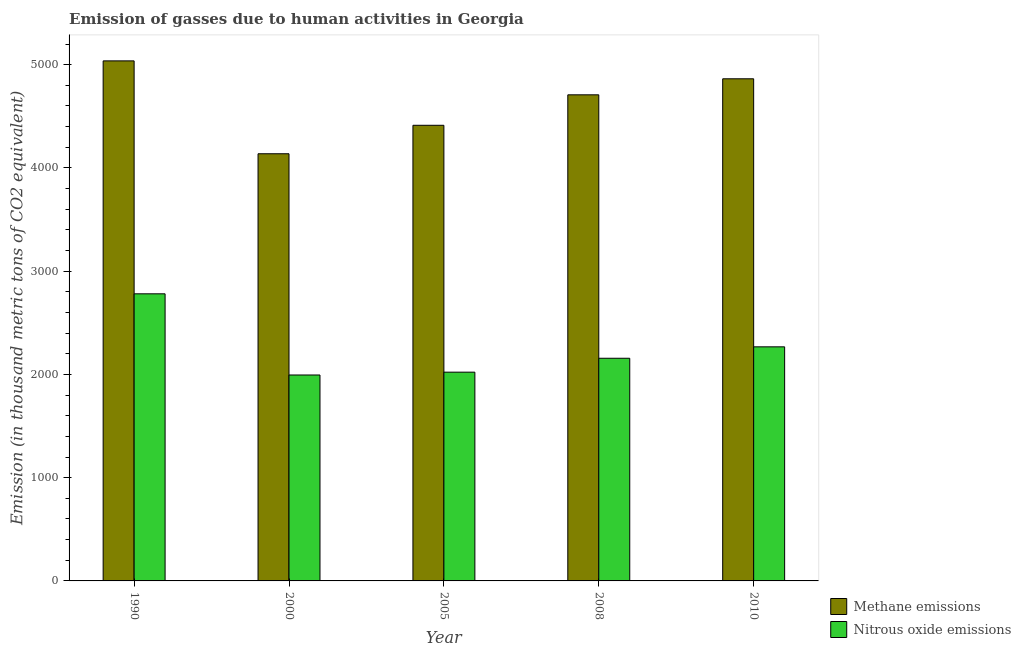Are the number of bars per tick equal to the number of legend labels?
Your answer should be compact. Yes. How many bars are there on the 5th tick from the left?
Make the answer very short. 2. What is the amount of nitrous oxide emissions in 2010?
Offer a very short reply. 2267.3. Across all years, what is the maximum amount of nitrous oxide emissions?
Give a very brief answer. 2780.8. Across all years, what is the minimum amount of nitrous oxide emissions?
Ensure brevity in your answer.  1994.5. In which year was the amount of nitrous oxide emissions maximum?
Your answer should be compact. 1990. What is the total amount of methane emissions in the graph?
Offer a terse response. 2.32e+04. What is the difference between the amount of methane emissions in 2005 and that in 2008?
Ensure brevity in your answer.  -295. What is the difference between the amount of methane emissions in 2000 and the amount of nitrous oxide emissions in 2010?
Provide a short and direct response. -726.1. What is the average amount of nitrous oxide emissions per year?
Provide a short and direct response. 2244.24. In the year 2010, what is the difference between the amount of nitrous oxide emissions and amount of methane emissions?
Keep it short and to the point. 0. In how many years, is the amount of nitrous oxide emissions greater than 4200 thousand metric tons?
Your answer should be compact. 0. What is the ratio of the amount of nitrous oxide emissions in 2000 to that in 2008?
Make the answer very short. 0.92. What is the difference between the highest and the second highest amount of methane emissions?
Your response must be concise. 173.5. What is the difference between the highest and the lowest amount of nitrous oxide emissions?
Your answer should be very brief. 786.3. What does the 1st bar from the left in 2008 represents?
Offer a terse response. Methane emissions. What does the 1st bar from the right in 2010 represents?
Your response must be concise. Nitrous oxide emissions. How many bars are there?
Make the answer very short. 10. How many years are there in the graph?
Give a very brief answer. 5. What is the difference between two consecutive major ticks on the Y-axis?
Give a very brief answer. 1000. Does the graph contain any zero values?
Your answer should be compact. No. Where does the legend appear in the graph?
Your response must be concise. Bottom right. How many legend labels are there?
Your response must be concise. 2. How are the legend labels stacked?
Offer a very short reply. Vertical. What is the title of the graph?
Offer a very short reply. Emission of gasses due to human activities in Georgia. Does "2012 US$" appear as one of the legend labels in the graph?
Your answer should be compact. No. What is the label or title of the X-axis?
Keep it short and to the point. Year. What is the label or title of the Y-axis?
Keep it short and to the point. Emission (in thousand metric tons of CO2 equivalent). What is the Emission (in thousand metric tons of CO2 equivalent) of Methane emissions in 1990?
Offer a terse response. 5037. What is the Emission (in thousand metric tons of CO2 equivalent) in Nitrous oxide emissions in 1990?
Your answer should be very brief. 2780.8. What is the Emission (in thousand metric tons of CO2 equivalent) in Methane emissions in 2000?
Give a very brief answer. 4137.4. What is the Emission (in thousand metric tons of CO2 equivalent) in Nitrous oxide emissions in 2000?
Provide a short and direct response. 1994.5. What is the Emission (in thousand metric tons of CO2 equivalent) of Methane emissions in 2005?
Ensure brevity in your answer.  4413.2. What is the Emission (in thousand metric tons of CO2 equivalent) of Nitrous oxide emissions in 2005?
Provide a short and direct response. 2022. What is the Emission (in thousand metric tons of CO2 equivalent) in Methane emissions in 2008?
Keep it short and to the point. 4708.2. What is the Emission (in thousand metric tons of CO2 equivalent) of Nitrous oxide emissions in 2008?
Your answer should be compact. 2156.6. What is the Emission (in thousand metric tons of CO2 equivalent) of Methane emissions in 2010?
Provide a succinct answer. 4863.5. What is the Emission (in thousand metric tons of CO2 equivalent) of Nitrous oxide emissions in 2010?
Make the answer very short. 2267.3. Across all years, what is the maximum Emission (in thousand metric tons of CO2 equivalent) of Methane emissions?
Provide a succinct answer. 5037. Across all years, what is the maximum Emission (in thousand metric tons of CO2 equivalent) of Nitrous oxide emissions?
Give a very brief answer. 2780.8. Across all years, what is the minimum Emission (in thousand metric tons of CO2 equivalent) in Methane emissions?
Give a very brief answer. 4137.4. Across all years, what is the minimum Emission (in thousand metric tons of CO2 equivalent) of Nitrous oxide emissions?
Offer a very short reply. 1994.5. What is the total Emission (in thousand metric tons of CO2 equivalent) in Methane emissions in the graph?
Ensure brevity in your answer.  2.32e+04. What is the total Emission (in thousand metric tons of CO2 equivalent) in Nitrous oxide emissions in the graph?
Offer a terse response. 1.12e+04. What is the difference between the Emission (in thousand metric tons of CO2 equivalent) in Methane emissions in 1990 and that in 2000?
Offer a terse response. 899.6. What is the difference between the Emission (in thousand metric tons of CO2 equivalent) of Nitrous oxide emissions in 1990 and that in 2000?
Your answer should be compact. 786.3. What is the difference between the Emission (in thousand metric tons of CO2 equivalent) in Methane emissions in 1990 and that in 2005?
Your answer should be very brief. 623.8. What is the difference between the Emission (in thousand metric tons of CO2 equivalent) of Nitrous oxide emissions in 1990 and that in 2005?
Keep it short and to the point. 758.8. What is the difference between the Emission (in thousand metric tons of CO2 equivalent) of Methane emissions in 1990 and that in 2008?
Give a very brief answer. 328.8. What is the difference between the Emission (in thousand metric tons of CO2 equivalent) of Nitrous oxide emissions in 1990 and that in 2008?
Your answer should be very brief. 624.2. What is the difference between the Emission (in thousand metric tons of CO2 equivalent) of Methane emissions in 1990 and that in 2010?
Provide a succinct answer. 173.5. What is the difference between the Emission (in thousand metric tons of CO2 equivalent) of Nitrous oxide emissions in 1990 and that in 2010?
Give a very brief answer. 513.5. What is the difference between the Emission (in thousand metric tons of CO2 equivalent) in Methane emissions in 2000 and that in 2005?
Ensure brevity in your answer.  -275.8. What is the difference between the Emission (in thousand metric tons of CO2 equivalent) in Nitrous oxide emissions in 2000 and that in 2005?
Offer a very short reply. -27.5. What is the difference between the Emission (in thousand metric tons of CO2 equivalent) of Methane emissions in 2000 and that in 2008?
Your response must be concise. -570.8. What is the difference between the Emission (in thousand metric tons of CO2 equivalent) of Nitrous oxide emissions in 2000 and that in 2008?
Keep it short and to the point. -162.1. What is the difference between the Emission (in thousand metric tons of CO2 equivalent) of Methane emissions in 2000 and that in 2010?
Offer a very short reply. -726.1. What is the difference between the Emission (in thousand metric tons of CO2 equivalent) in Nitrous oxide emissions in 2000 and that in 2010?
Your answer should be compact. -272.8. What is the difference between the Emission (in thousand metric tons of CO2 equivalent) of Methane emissions in 2005 and that in 2008?
Offer a terse response. -295. What is the difference between the Emission (in thousand metric tons of CO2 equivalent) in Nitrous oxide emissions in 2005 and that in 2008?
Ensure brevity in your answer.  -134.6. What is the difference between the Emission (in thousand metric tons of CO2 equivalent) of Methane emissions in 2005 and that in 2010?
Give a very brief answer. -450.3. What is the difference between the Emission (in thousand metric tons of CO2 equivalent) of Nitrous oxide emissions in 2005 and that in 2010?
Offer a very short reply. -245.3. What is the difference between the Emission (in thousand metric tons of CO2 equivalent) of Methane emissions in 2008 and that in 2010?
Your answer should be compact. -155.3. What is the difference between the Emission (in thousand metric tons of CO2 equivalent) in Nitrous oxide emissions in 2008 and that in 2010?
Offer a very short reply. -110.7. What is the difference between the Emission (in thousand metric tons of CO2 equivalent) of Methane emissions in 1990 and the Emission (in thousand metric tons of CO2 equivalent) of Nitrous oxide emissions in 2000?
Keep it short and to the point. 3042.5. What is the difference between the Emission (in thousand metric tons of CO2 equivalent) of Methane emissions in 1990 and the Emission (in thousand metric tons of CO2 equivalent) of Nitrous oxide emissions in 2005?
Ensure brevity in your answer.  3015. What is the difference between the Emission (in thousand metric tons of CO2 equivalent) in Methane emissions in 1990 and the Emission (in thousand metric tons of CO2 equivalent) in Nitrous oxide emissions in 2008?
Keep it short and to the point. 2880.4. What is the difference between the Emission (in thousand metric tons of CO2 equivalent) in Methane emissions in 1990 and the Emission (in thousand metric tons of CO2 equivalent) in Nitrous oxide emissions in 2010?
Keep it short and to the point. 2769.7. What is the difference between the Emission (in thousand metric tons of CO2 equivalent) of Methane emissions in 2000 and the Emission (in thousand metric tons of CO2 equivalent) of Nitrous oxide emissions in 2005?
Make the answer very short. 2115.4. What is the difference between the Emission (in thousand metric tons of CO2 equivalent) of Methane emissions in 2000 and the Emission (in thousand metric tons of CO2 equivalent) of Nitrous oxide emissions in 2008?
Make the answer very short. 1980.8. What is the difference between the Emission (in thousand metric tons of CO2 equivalent) in Methane emissions in 2000 and the Emission (in thousand metric tons of CO2 equivalent) in Nitrous oxide emissions in 2010?
Your answer should be very brief. 1870.1. What is the difference between the Emission (in thousand metric tons of CO2 equivalent) in Methane emissions in 2005 and the Emission (in thousand metric tons of CO2 equivalent) in Nitrous oxide emissions in 2008?
Ensure brevity in your answer.  2256.6. What is the difference between the Emission (in thousand metric tons of CO2 equivalent) of Methane emissions in 2005 and the Emission (in thousand metric tons of CO2 equivalent) of Nitrous oxide emissions in 2010?
Offer a very short reply. 2145.9. What is the difference between the Emission (in thousand metric tons of CO2 equivalent) in Methane emissions in 2008 and the Emission (in thousand metric tons of CO2 equivalent) in Nitrous oxide emissions in 2010?
Ensure brevity in your answer.  2440.9. What is the average Emission (in thousand metric tons of CO2 equivalent) in Methane emissions per year?
Offer a very short reply. 4631.86. What is the average Emission (in thousand metric tons of CO2 equivalent) in Nitrous oxide emissions per year?
Make the answer very short. 2244.24. In the year 1990, what is the difference between the Emission (in thousand metric tons of CO2 equivalent) in Methane emissions and Emission (in thousand metric tons of CO2 equivalent) in Nitrous oxide emissions?
Make the answer very short. 2256.2. In the year 2000, what is the difference between the Emission (in thousand metric tons of CO2 equivalent) of Methane emissions and Emission (in thousand metric tons of CO2 equivalent) of Nitrous oxide emissions?
Make the answer very short. 2142.9. In the year 2005, what is the difference between the Emission (in thousand metric tons of CO2 equivalent) of Methane emissions and Emission (in thousand metric tons of CO2 equivalent) of Nitrous oxide emissions?
Your answer should be compact. 2391.2. In the year 2008, what is the difference between the Emission (in thousand metric tons of CO2 equivalent) of Methane emissions and Emission (in thousand metric tons of CO2 equivalent) of Nitrous oxide emissions?
Keep it short and to the point. 2551.6. In the year 2010, what is the difference between the Emission (in thousand metric tons of CO2 equivalent) of Methane emissions and Emission (in thousand metric tons of CO2 equivalent) of Nitrous oxide emissions?
Your response must be concise. 2596.2. What is the ratio of the Emission (in thousand metric tons of CO2 equivalent) in Methane emissions in 1990 to that in 2000?
Provide a succinct answer. 1.22. What is the ratio of the Emission (in thousand metric tons of CO2 equivalent) in Nitrous oxide emissions in 1990 to that in 2000?
Provide a succinct answer. 1.39. What is the ratio of the Emission (in thousand metric tons of CO2 equivalent) of Methane emissions in 1990 to that in 2005?
Keep it short and to the point. 1.14. What is the ratio of the Emission (in thousand metric tons of CO2 equivalent) in Nitrous oxide emissions in 1990 to that in 2005?
Offer a very short reply. 1.38. What is the ratio of the Emission (in thousand metric tons of CO2 equivalent) in Methane emissions in 1990 to that in 2008?
Offer a terse response. 1.07. What is the ratio of the Emission (in thousand metric tons of CO2 equivalent) of Nitrous oxide emissions in 1990 to that in 2008?
Provide a succinct answer. 1.29. What is the ratio of the Emission (in thousand metric tons of CO2 equivalent) in Methane emissions in 1990 to that in 2010?
Keep it short and to the point. 1.04. What is the ratio of the Emission (in thousand metric tons of CO2 equivalent) in Nitrous oxide emissions in 1990 to that in 2010?
Keep it short and to the point. 1.23. What is the ratio of the Emission (in thousand metric tons of CO2 equivalent) of Methane emissions in 2000 to that in 2005?
Offer a terse response. 0.94. What is the ratio of the Emission (in thousand metric tons of CO2 equivalent) of Nitrous oxide emissions in 2000 to that in 2005?
Your answer should be very brief. 0.99. What is the ratio of the Emission (in thousand metric tons of CO2 equivalent) of Methane emissions in 2000 to that in 2008?
Offer a very short reply. 0.88. What is the ratio of the Emission (in thousand metric tons of CO2 equivalent) in Nitrous oxide emissions in 2000 to that in 2008?
Your answer should be compact. 0.92. What is the ratio of the Emission (in thousand metric tons of CO2 equivalent) in Methane emissions in 2000 to that in 2010?
Your answer should be compact. 0.85. What is the ratio of the Emission (in thousand metric tons of CO2 equivalent) in Nitrous oxide emissions in 2000 to that in 2010?
Make the answer very short. 0.88. What is the ratio of the Emission (in thousand metric tons of CO2 equivalent) of Methane emissions in 2005 to that in 2008?
Make the answer very short. 0.94. What is the ratio of the Emission (in thousand metric tons of CO2 equivalent) in Nitrous oxide emissions in 2005 to that in 2008?
Keep it short and to the point. 0.94. What is the ratio of the Emission (in thousand metric tons of CO2 equivalent) of Methane emissions in 2005 to that in 2010?
Make the answer very short. 0.91. What is the ratio of the Emission (in thousand metric tons of CO2 equivalent) of Nitrous oxide emissions in 2005 to that in 2010?
Keep it short and to the point. 0.89. What is the ratio of the Emission (in thousand metric tons of CO2 equivalent) in Methane emissions in 2008 to that in 2010?
Offer a terse response. 0.97. What is the ratio of the Emission (in thousand metric tons of CO2 equivalent) in Nitrous oxide emissions in 2008 to that in 2010?
Your response must be concise. 0.95. What is the difference between the highest and the second highest Emission (in thousand metric tons of CO2 equivalent) of Methane emissions?
Your answer should be compact. 173.5. What is the difference between the highest and the second highest Emission (in thousand metric tons of CO2 equivalent) of Nitrous oxide emissions?
Your response must be concise. 513.5. What is the difference between the highest and the lowest Emission (in thousand metric tons of CO2 equivalent) in Methane emissions?
Provide a succinct answer. 899.6. What is the difference between the highest and the lowest Emission (in thousand metric tons of CO2 equivalent) in Nitrous oxide emissions?
Offer a very short reply. 786.3. 